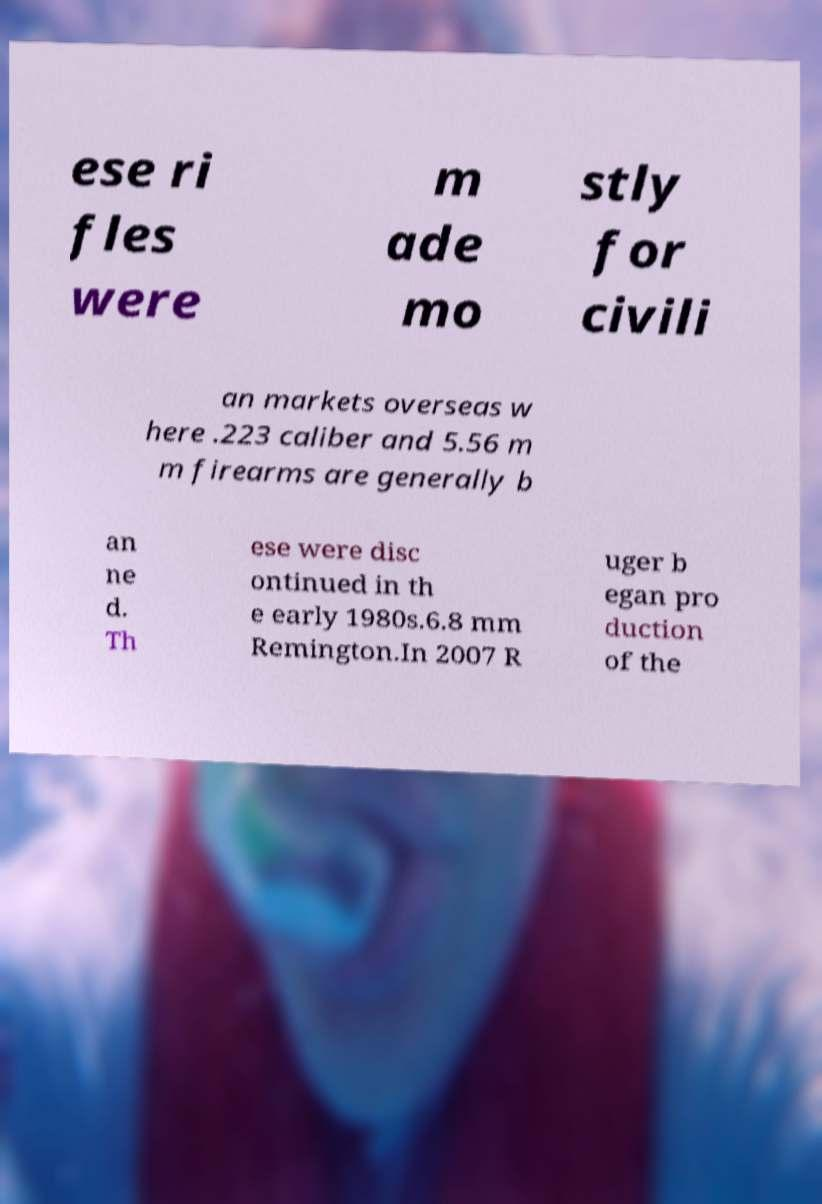Could you assist in decoding the text presented in this image and type it out clearly? ese ri fles were m ade mo stly for civili an markets overseas w here .223 caliber and 5.56 m m firearms are generally b an ne d. Th ese were disc ontinued in th e early 1980s.6.8 mm Remington.In 2007 R uger b egan pro duction of the 